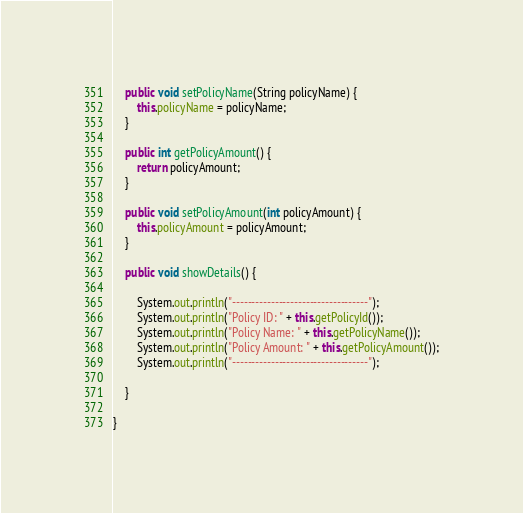<code> <loc_0><loc_0><loc_500><loc_500><_Java_>
	public void setPolicyName(String policyName) {
		this.policyName = policyName;
	}

	public int getPolicyAmount() {
		return policyAmount;
	}

	public void setPolicyAmount(int policyAmount) {
		this.policyAmount = policyAmount;
	}

	public void showDetails() {
		
		System.out.println("-----------------------------------");
		System.out.println("Policy ID: " + this.getPolicyId());
		System.out.println("Policy Name: " + this.getPolicyName());
		System.out.println("Policy Amount: " + this.getPolicyAmount());
		System.out.println("-----------------------------------");

	}

}</code> 